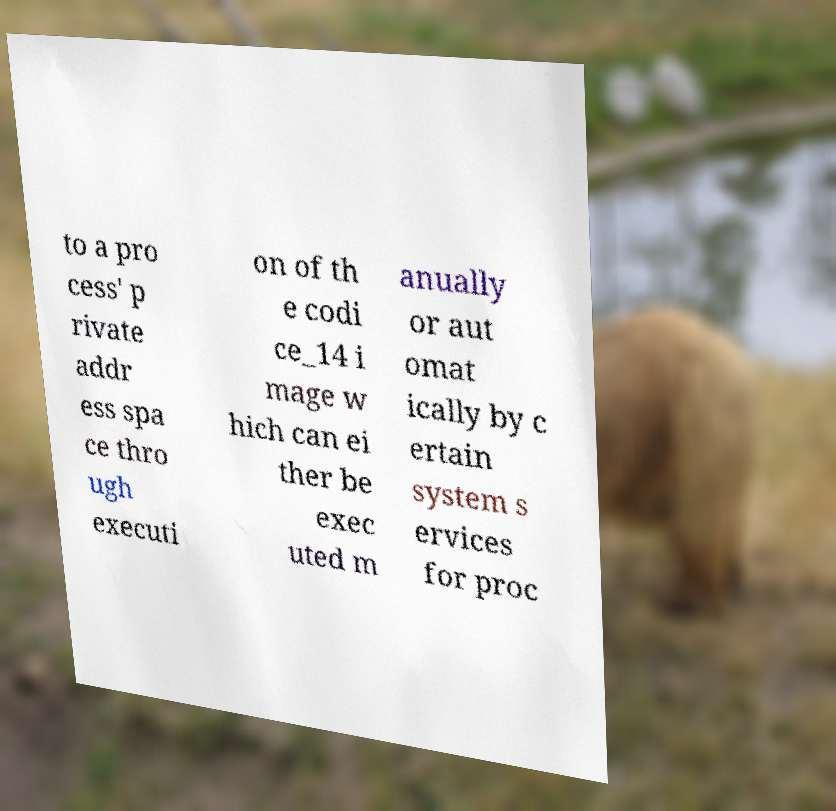Please read and relay the text visible in this image. What does it say? to a pro cess' p rivate addr ess spa ce thro ugh executi on of th e codi ce_14 i mage w hich can ei ther be exec uted m anually or aut omat ically by c ertain system s ervices for proc 